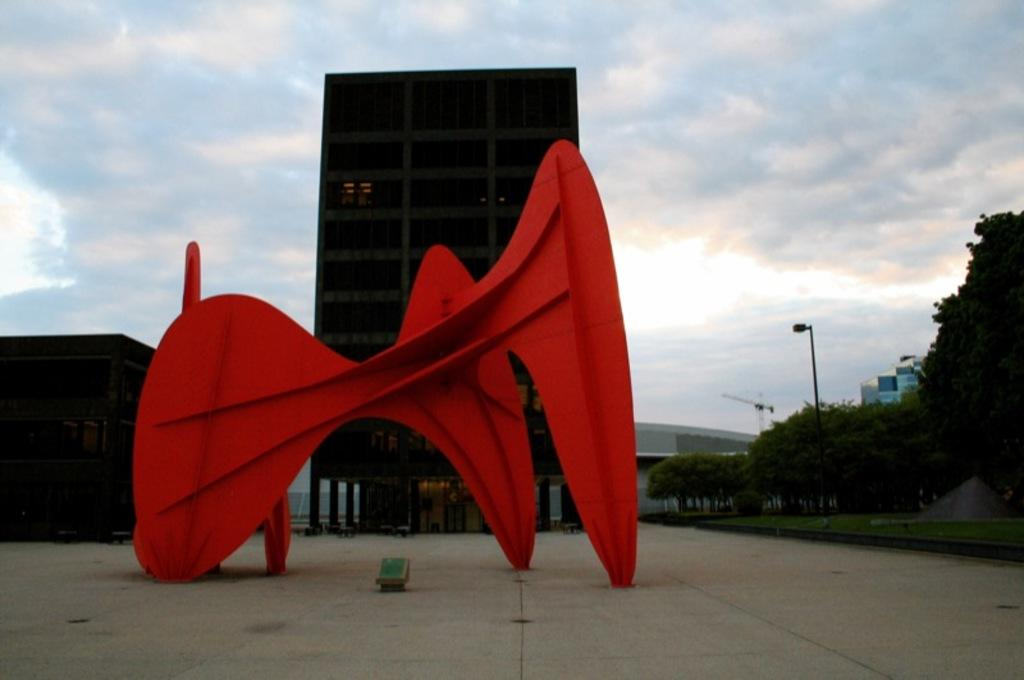What type of structures can be seen in the image? There are buildings in the image. What other natural elements are present in the image? There are trees in the image. What artificial light source is visible in the image? There is a street lamp in the image. What is visible in the background of the image? The sky is visible in the image. What atmospheric conditions can be observed in the sky? Clouds are present in the sky. Reasoning: Let' Let's think step by step in order to produce the conversation. We start by identifying the main subjects and objects in the image based on the provided facts. We then formulate questions that focus on the location and characteristics of these subjects and objects, ensuring that each question can be answered definitively with the information given. We avoid yes/no questions and ensure that the language is simple and clear. Absurd Question/Answer: Can you see a rabbit hopping through the fog in the image? There is no rabbit or fog present in the image; it features buildings, trees, a street lamp, and a sky with clouds. Are there any fish visible in the image? There are no fish present in the image. Can you see any fish swimming in the water near the buildings in the image? There is no water or fish present in the image; it features include buildings, trees, a street lamp, and a sky with clouds. 